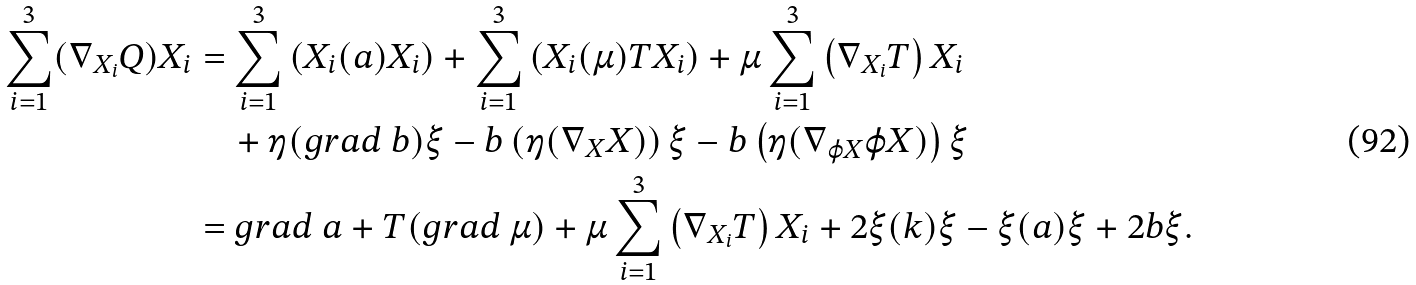<formula> <loc_0><loc_0><loc_500><loc_500>\sum _ { i = 1 } ^ { 3 } ( \nabla _ { X _ { i } } Q ) X _ { i } & = \sum _ { i = 1 } ^ { 3 } \left ( X _ { i } ( a ) X _ { i } \right ) + \sum _ { i = 1 } ^ { 3 } \left ( X _ { i } ( \mu ) T X _ { i } \right ) + \mu \sum _ { i = 1 } ^ { 3 } \left ( \nabla _ { X _ { i } } T \right ) X _ { i } \\ & \quad + \eta ( g r a d \ b ) \xi - b \left ( \eta ( \nabla _ { X } X ) \right ) \xi - b \left ( \eta ( \nabla _ { \varphi X } \varphi X ) \right ) \xi \\ & = g r a d \ a + T ( g r a d \ \mu ) + \mu \sum _ { i = 1 } ^ { 3 } \left ( \nabla _ { X _ { i } } T \right ) X _ { i } + 2 \xi ( k ) \xi - \xi ( a ) \xi + 2 b \xi .</formula> 